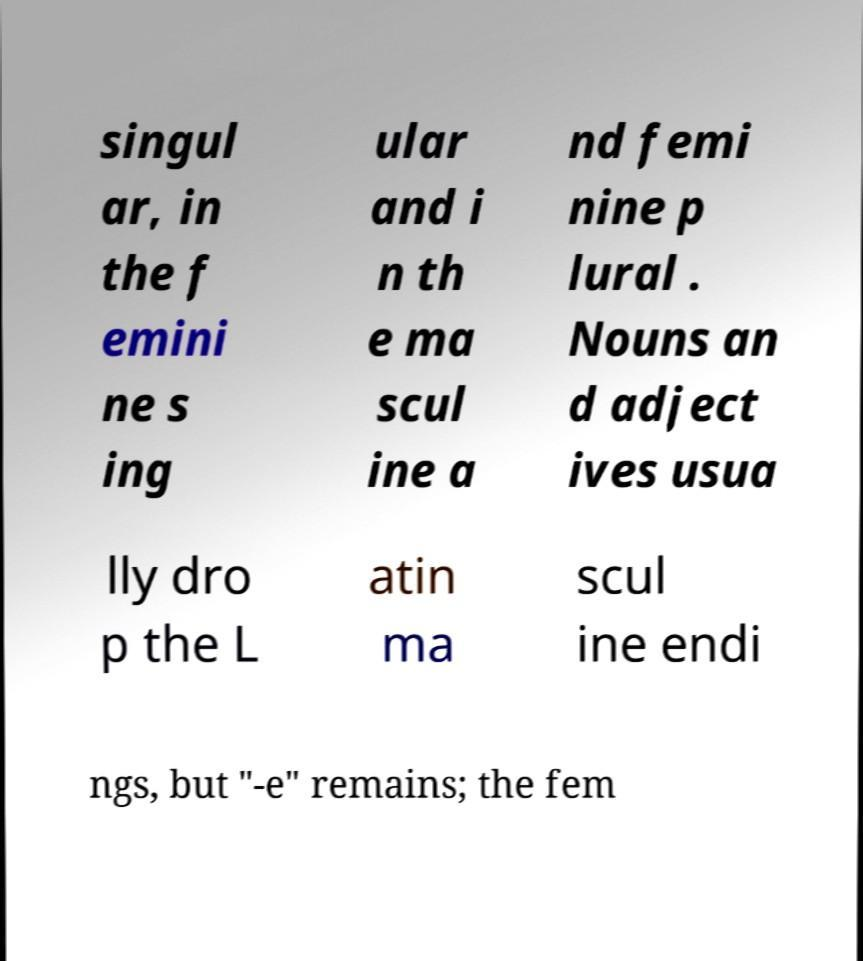Can you read and provide the text displayed in the image?This photo seems to have some interesting text. Can you extract and type it out for me? singul ar, in the f emini ne s ing ular and i n th e ma scul ine a nd femi nine p lural . Nouns an d adject ives usua lly dro p the L atin ma scul ine endi ngs, but "-e" remains; the fem 